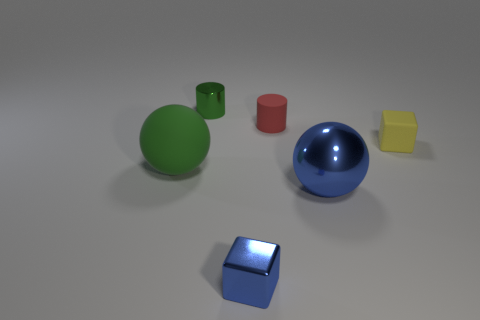Add 2 purple shiny objects. How many objects exist? 8 Subtract 2 cylinders. How many cylinders are left? 0 Subtract all blocks. How many objects are left? 4 Subtract all yellow cylinders. How many blue spheres are left? 1 Subtract all small blue metal objects. Subtract all small yellow matte objects. How many objects are left? 4 Add 2 blue metal things. How many blue metal things are left? 4 Add 4 green balls. How many green balls exist? 5 Subtract 1 blue cubes. How many objects are left? 5 Subtract all yellow cylinders. Subtract all red blocks. How many cylinders are left? 2 